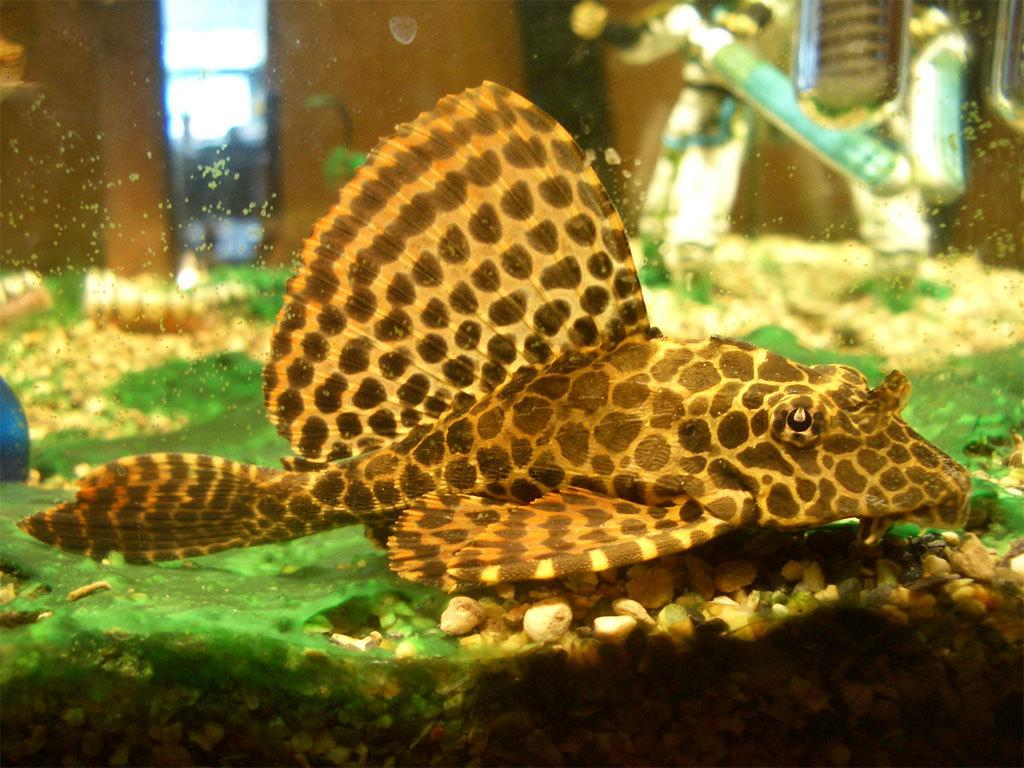What type of environment is depicted in the image? The image appears to be an aquarium. What can be found at the bottom of the aquarium? There are stones at the bottom of the aquarium. What type of bell can be heard ringing in the image? There is no bell present in the image, as it is an aquarium with stones at the bottom. 